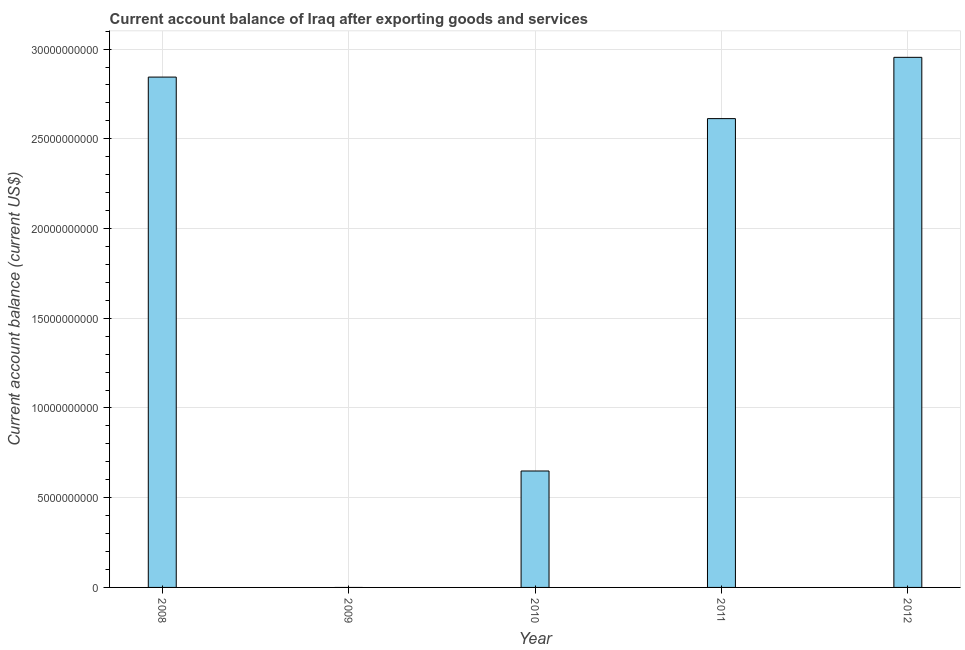What is the title of the graph?
Provide a succinct answer. Current account balance of Iraq after exporting goods and services. What is the label or title of the X-axis?
Make the answer very short. Year. What is the label or title of the Y-axis?
Provide a short and direct response. Current account balance (current US$). What is the current account balance in 2011?
Offer a terse response. 2.61e+1. Across all years, what is the maximum current account balance?
Provide a short and direct response. 2.95e+1. What is the sum of the current account balance?
Give a very brief answer. 9.06e+1. What is the difference between the current account balance in 2010 and 2011?
Provide a succinct answer. -1.96e+1. What is the average current account balance per year?
Offer a very short reply. 1.81e+1. What is the median current account balance?
Provide a succinct answer. 2.61e+1. In how many years, is the current account balance greater than 6000000000 US$?
Keep it short and to the point. 4. What is the ratio of the current account balance in 2008 to that in 2010?
Give a very brief answer. 4.38. Is the current account balance in 2008 less than that in 2011?
Make the answer very short. No. What is the difference between the highest and the second highest current account balance?
Keep it short and to the point. 1.10e+09. Is the sum of the current account balance in 2008 and 2010 greater than the maximum current account balance across all years?
Give a very brief answer. Yes. What is the difference between the highest and the lowest current account balance?
Make the answer very short. 2.95e+1. In how many years, is the current account balance greater than the average current account balance taken over all years?
Offer a terse response. 3. How many bars are there?
Provide a short and direct response. 4. Are the values on the major ticks of Y-axis written in scientific E-notation?
Offer a terse response. No. What is the Current account balance (current US$) of 2008?
Ensure brevity in your answer.  2.84e+1. What is the Current account balance (current US$) in 2009?
Your response must be concise. 0. What is the Current account balance (current US$) of 2010?
Ensure brevity in your answer.  6.49e+09. What is the Current account balance (current US$) in 2011?
Provide a succinct answer. 2.61e+1. What is the Current account balance (current US$) in 2012?
Provide a short and direct response. 2.95e+1. What is the difference between the Current account balance (current US$) in 2008 and 2010?
Your response must be concise. 2.20e+1. What is the difference between the Current account balance (current US$) in 2008 and 2011?
Your answer should be very brief. 2.31e+09. What is the difference between the Current account balance (current US$) in 2008 and 2012?
Your response must be concise. -1.10e+09. What is the difference between the Current account balance (current US$) in 2010 and 2011?
Make the answer very short. -1.96e+1. What is the difference between the Current account balance (current US$) in 2010 and 2012?
Your answer should be compact. -2.31e+1. What is the difference between the Current account balance (current US$) in 2011 and 2012?
Offer a terse response. -3.42e+09. What is the ratio of the Current account balance (current US$) in 2008 to that in 2010?
Make the answer very short. 4.38. What is the ratio of the Current account balance (current US$) in 2008 to that in 2011?
Make the answer very short. 1.09. What is the ratio of the Current account balance (current US$) in 2008 to that in 2012?
Your answer should be compact. 0.96. What is the ratio of the Current account balance (current US$) in 2010 to that in 2011?
Your answer should be very brief. 0.25. What is the ratio of the Current account balance (current US$) in 2010 to that in 2012?
Provide a succinct answer. 0.22. What is the ratio of the Current account balance (current US$) in 2011 to that in 2012?
Your answer should be very brief. 0.88. 